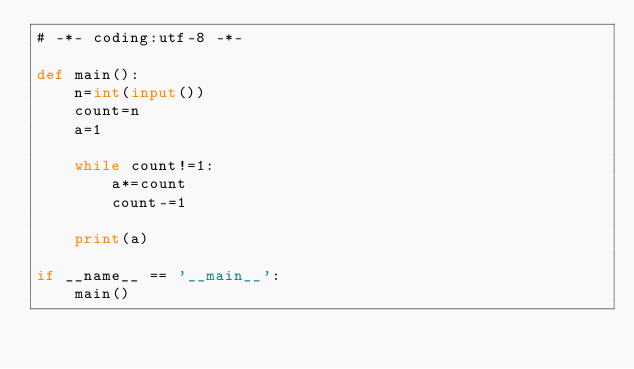<code> <loc_0><loc_0><loc_500><loc_500><_Python_># -*- coding:utf-8 -*-

def main():
    n=int(input())
    count=n
    a=1

    while count!=1:
        a*=count
        count-=1

    print(a)
        
if __name__ == '__main__':
    main()</code> 